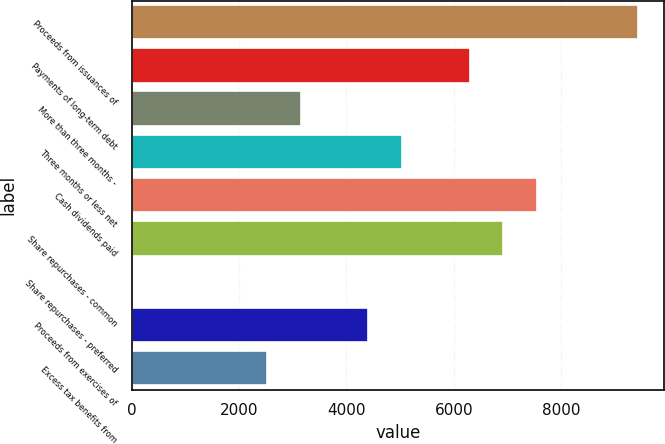Convert chart. <chart><loc_0><loc_0><loc_500><loc_500><bar_chart><fcel>Proceeds from issuances of<fcel>Payments of long-term debt<fcel>More than three months -<fcel>Three months or less net<fcel>Cash dividends paid<fcel>Share repurchases - common<fcel>Share repurchases - preferred<fcel>Proceeds from exercises of<fcel>Excess tax benefits from<nl><fcel>9442<fcel>6297<fcel>3152<fcel>5039<fcel>7555<fcel>6926<fcel>7<fcel>4410<fcel>2523<nl></chart> 